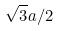<formula> <loc_0><loc_0><loc_500><loc_500>\sqrt { 3 } a / 2</formula> 